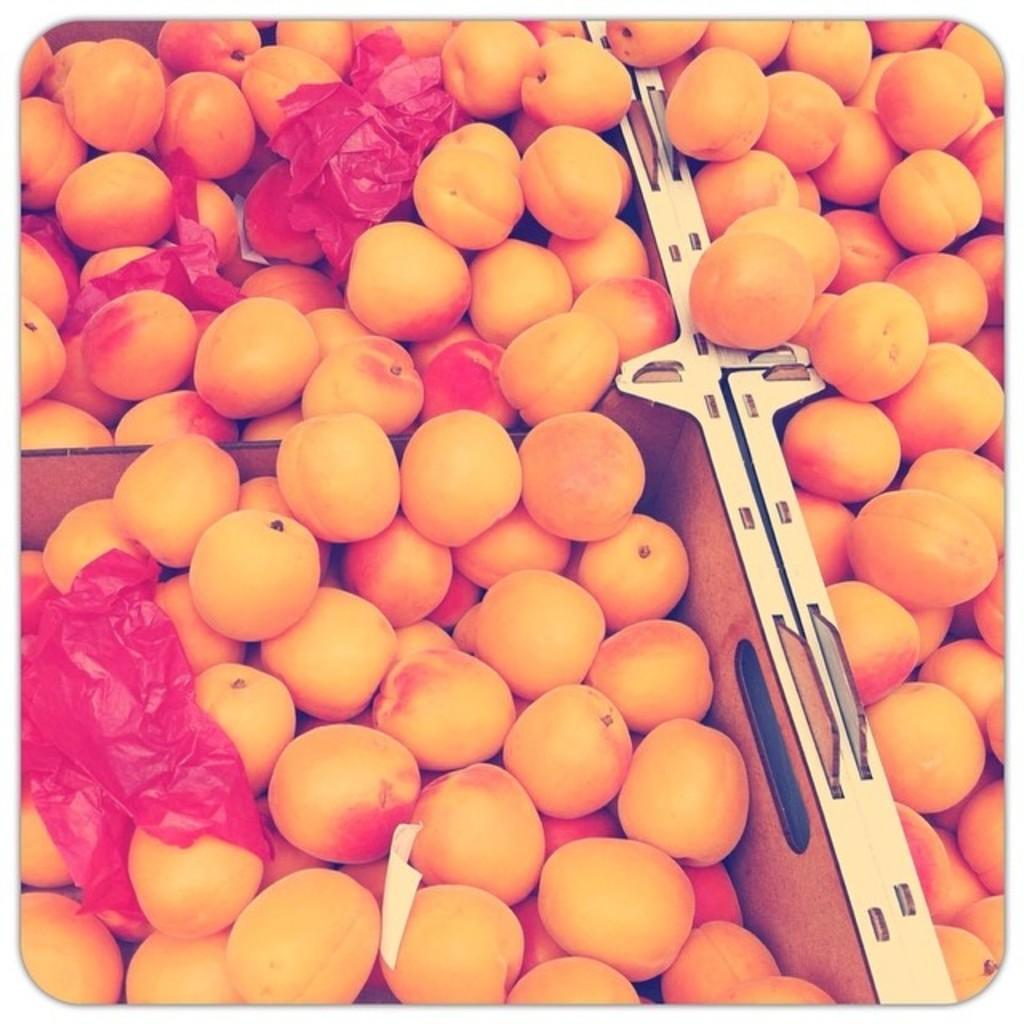Can you describe this image briefly? There are fruits arranged along with red color covers in the boxes. 